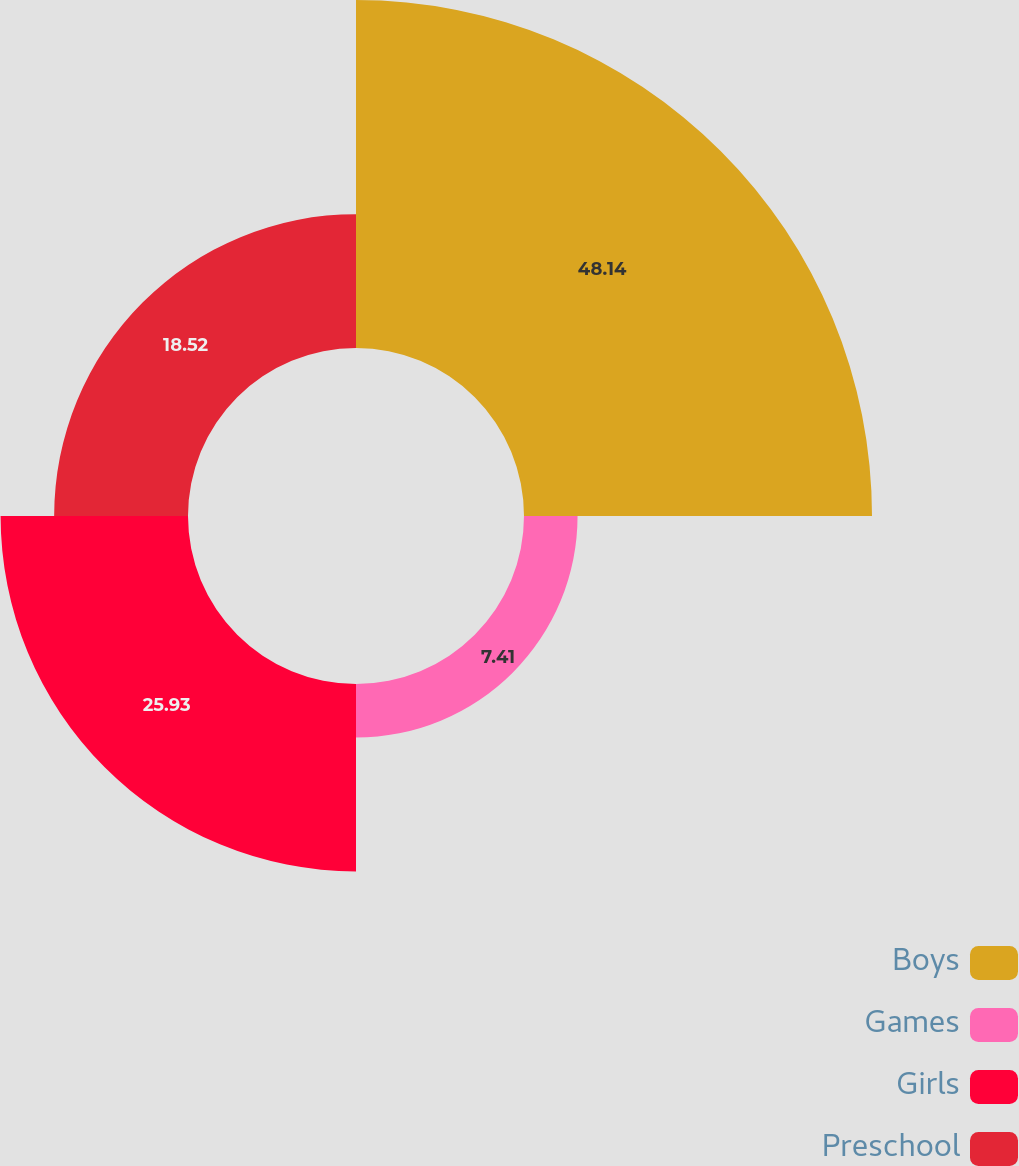Convert chart to OTSL. <chart><loc_0><loc_0><loc_500><loc_500><pie_chart><fcel>Boys<fcel>Games<fcel>Girls<fcel>Preschool<nl><fcel>48.15%<fcel>7.41%<fcel>25.93%<fcel>18.52%<nl></chart> 